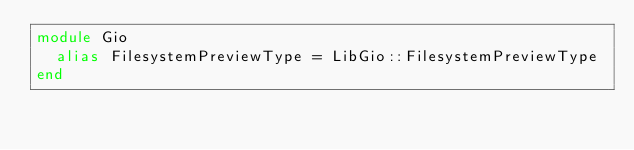Convert code to text. <code><loc_0><loc_0><loc_500><loc_500><_Crystal_>module Gio
  alias FilesystemPreviewType = LibGio::FilesystemPreviewType
end

</code> 